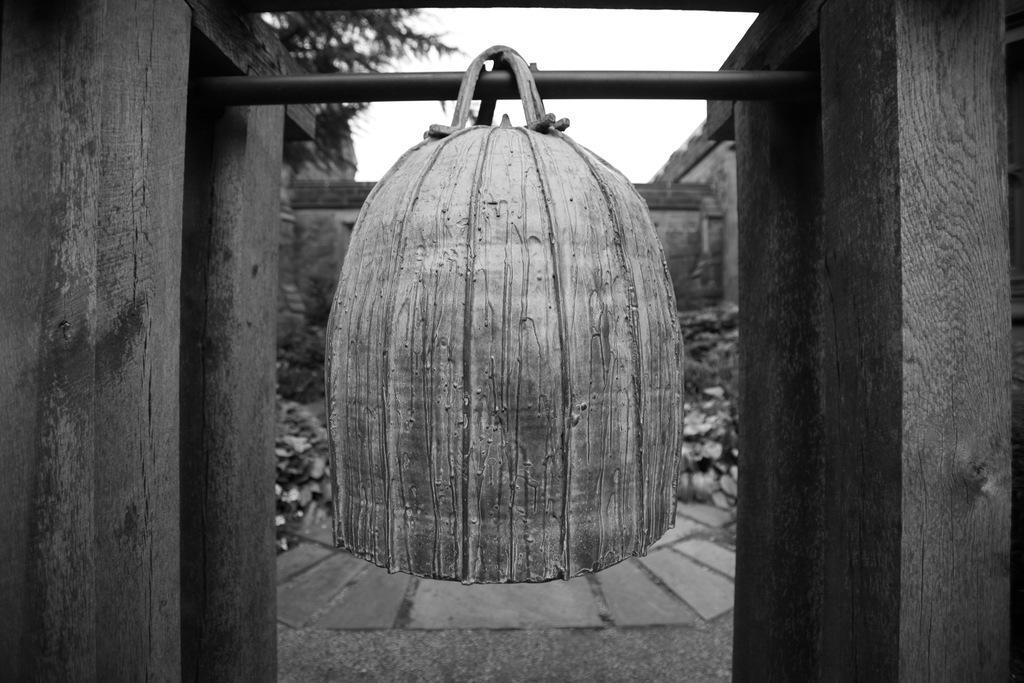In one or two sentences, can you explain what this image depicts? It is a black and white picture. Here it looks like a bell on a rod. On the right side and left side, we can see wooden objects. Background we can see the blur view. At the bottom, we can see the walkway. Top of the image, there is the sky and tree. 